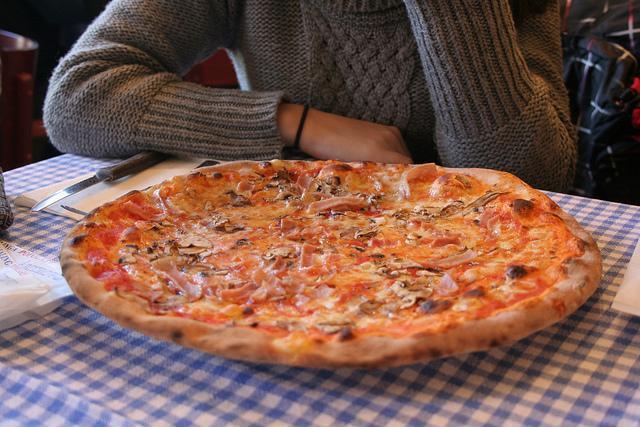How many white sheep are in this shot?
Give a very brief answer. 0. 